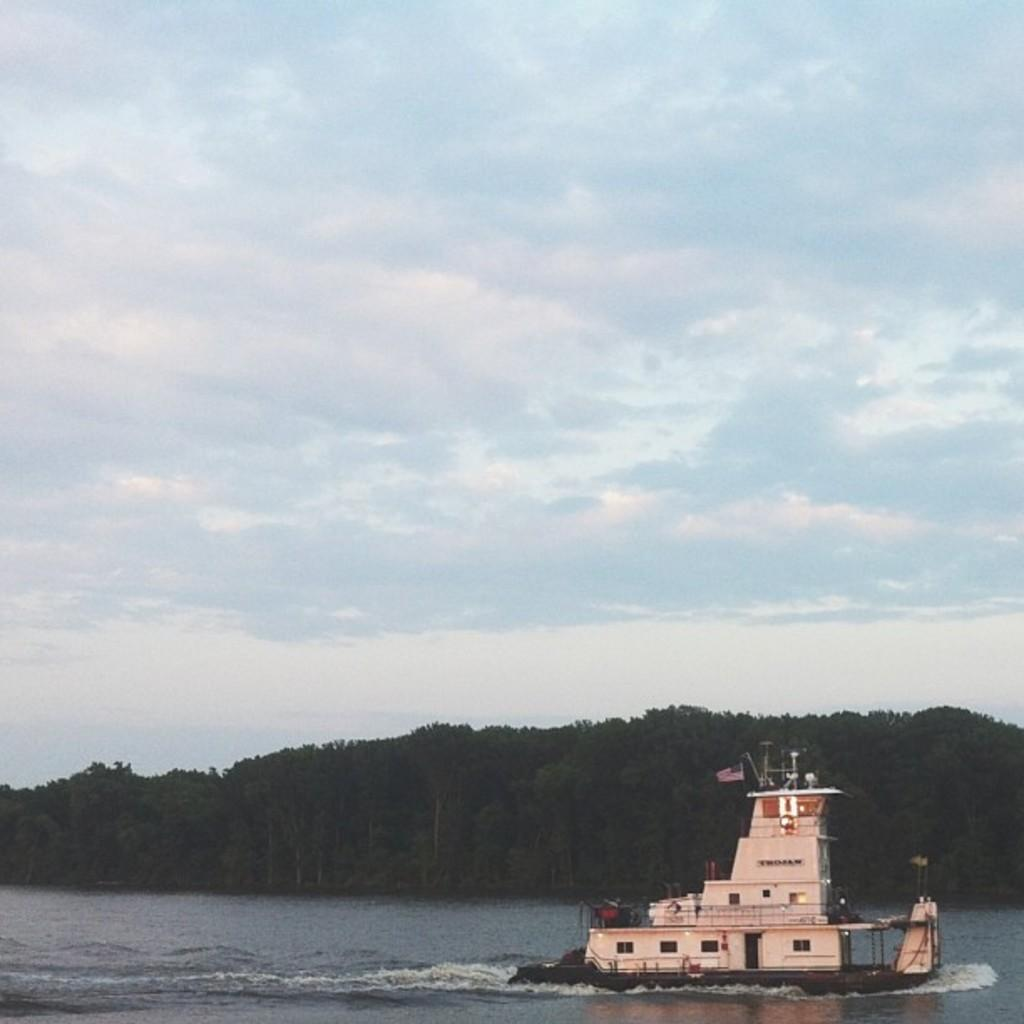What is the main subject of the image? There is a ship in the image. Where is the ship located? The ship is on the water. What is the color of the ship? The ship is white in color. What can be seen in the background of the image? There are trees, clouds, and the sky visible in the background of the image. What type of shape is the shelf in the image? There is no shelf present in the image. 